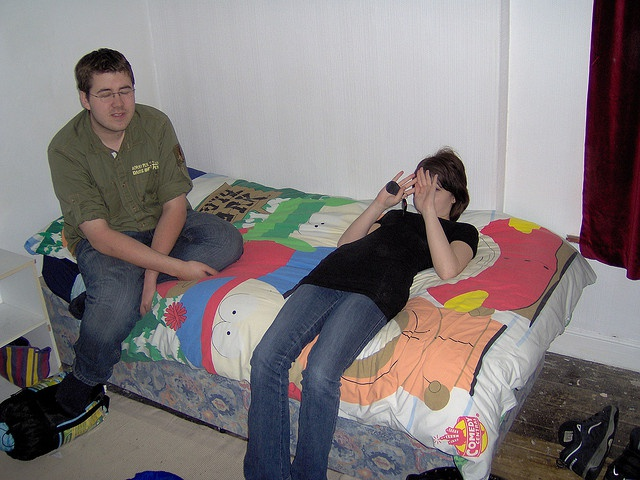Describe the objects in this image and their specific colors. I can see bed in darkgray, gray, brown, and lightgray tones, people in darkgray, gray, black, and darkgreen tones, people in darkgray, black, navy, gray, and darkblue tones, and handbag in darkgray, black, olive, purple, and navy tones in this image. 